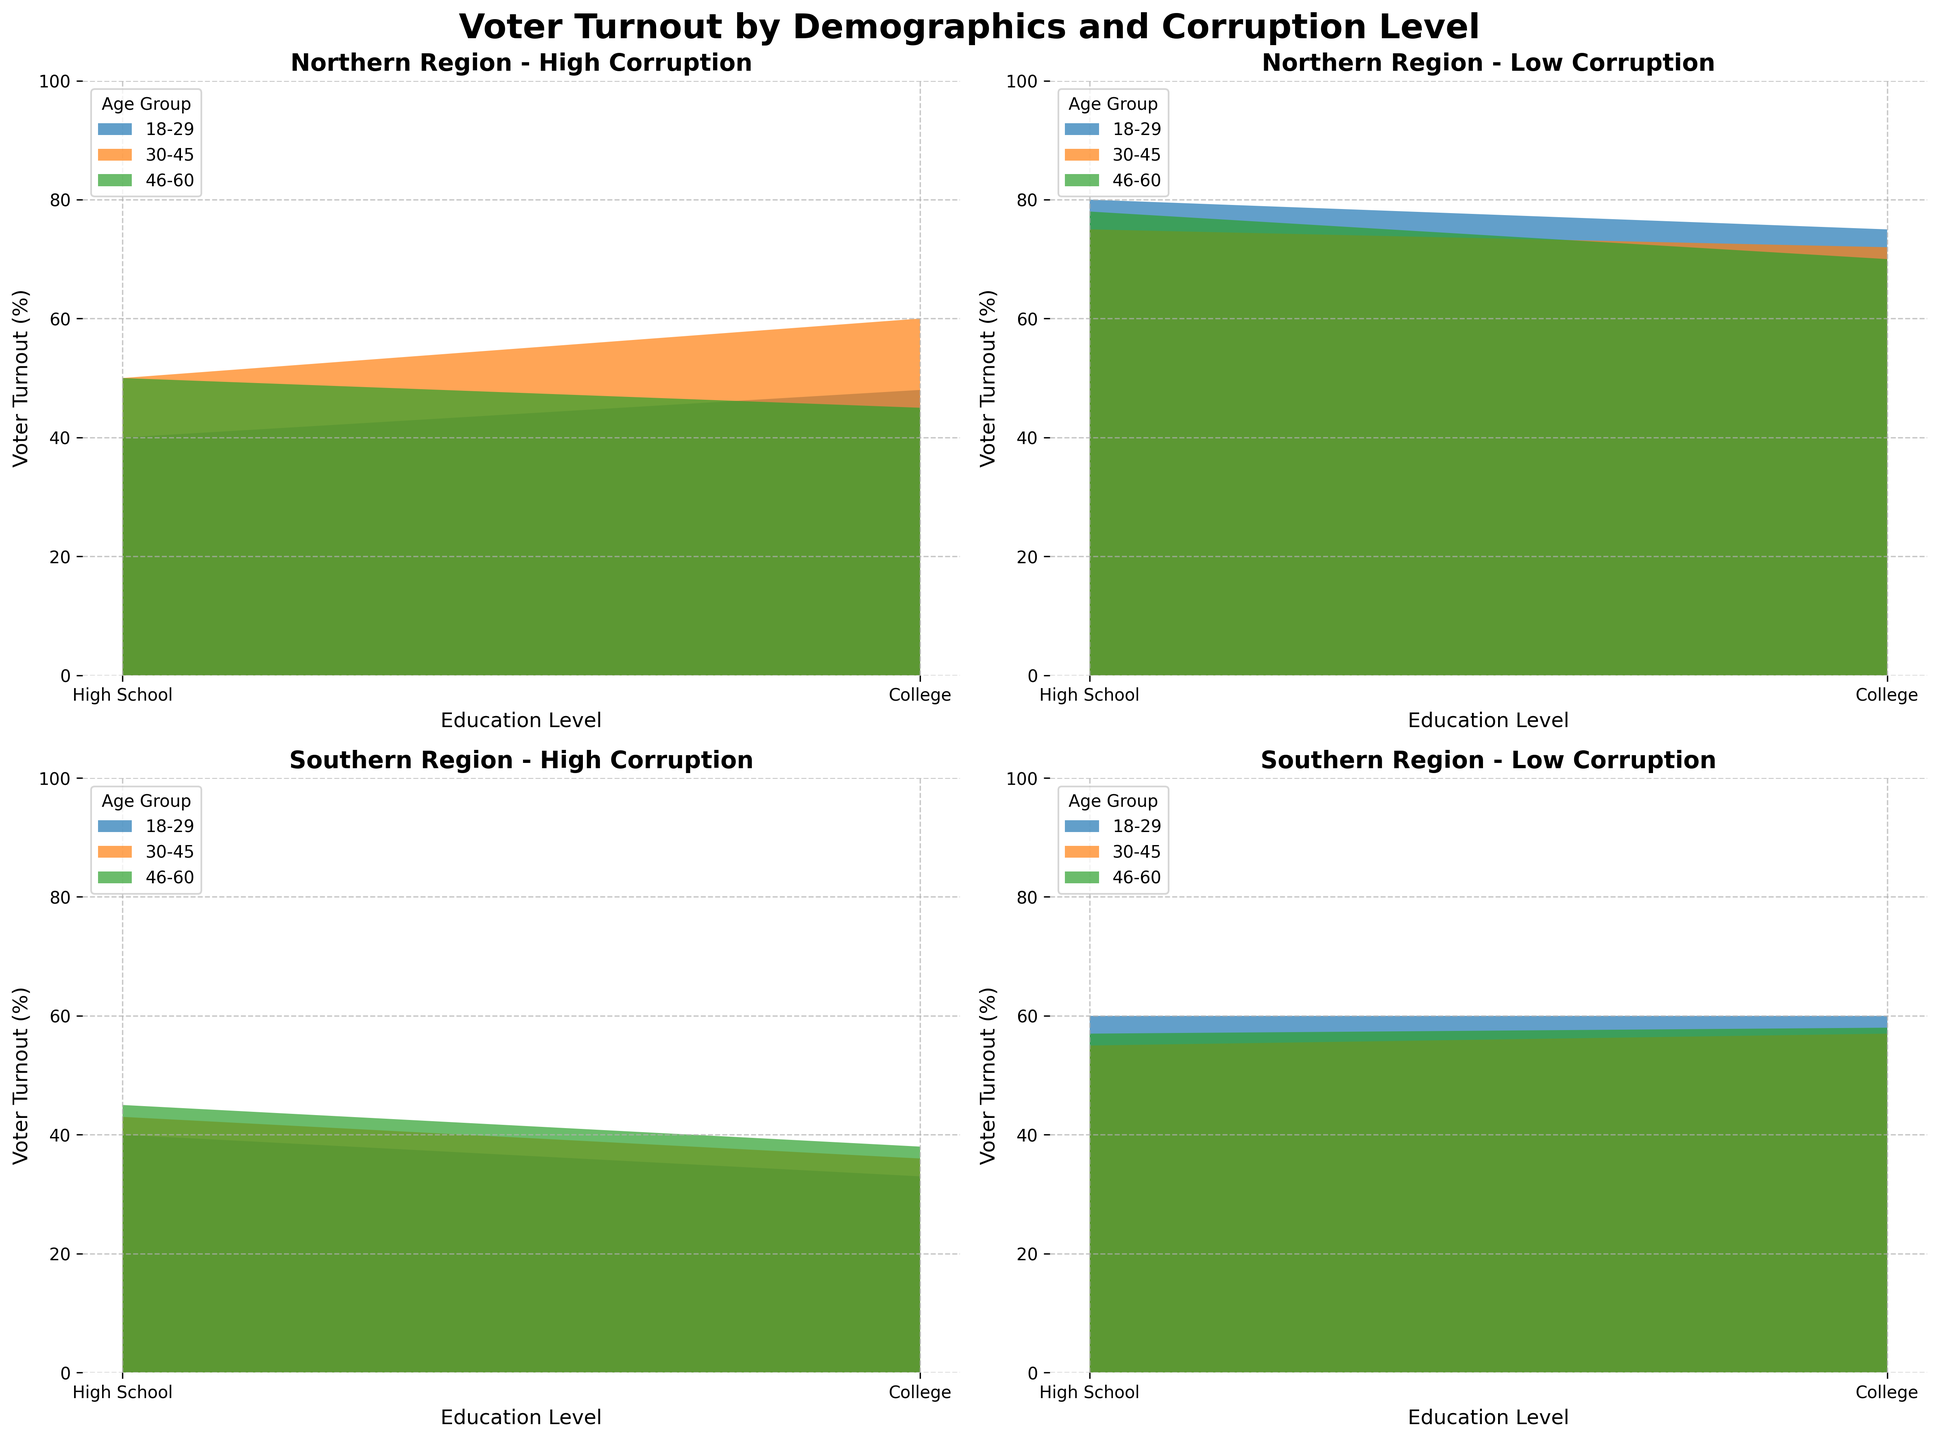What title is displayed at the top of the figure? The title is specified by the `suptitle` parameter in the `fig.suptitle` function. It should be evident at the very top center of the figure.
Answer: Voter Turnout by Demographics and Corruption Level How does voter turnout among college-educated individuals in the Northern region differ between high and low corruption levels? Observe the area charts for the Northern region under the high and low corruption conditions. Specifically, look at the differences in the voter turnout rates for the college-educated subgroup.
Answer: Higher in low corruption level Which age group generally has the highest voter turnout in regions with low corruption? Examine the area corresponding to the low corruption levels for both Northern and Southern regions. The highest area peak across the age groups will indicate the group with the highest voter turnout.
Answer: 18-29 Is there a noticeable difference in voter turnout between high school and college-educated individuals in the Southern region with low corruption? Compare the voter turnout areas for high school versus college education in the Southern region with low corruption. Look for general trends and differences in the areas representing these education levels.
Answer: Higher for college-educated In regions with high corruption, which age group tends to have the highest voter turnout for the Southern region? Look at the subplots for the Southern region with high corruption and identify the age group with the highest peaks in voter turnout.
Answer: 46-60 How does voter turnout among different age groups with high education level compare in both regions under low corruption? Compare the area charts for the college-educated individuals under low corruption for both Northern and Southern regions across different age groups. Determine which age group has consistently higher turnout.
Answer: Northern has higher turnout for 18-29 and 30-45, Southern for 46-60 What's the trend in voter turnout for the 30-45 age group in the Northern region under high and low corruption levels? Observe the specific area chart for the 30-45 age group in the Northern region. Compare the trends between high and low corruption levels for this group.
Answer: Increasing from high to low corruption Does the 46-60 age group in the Southern region show more voter turnout in high corruption areas compared to the Northern region? Compare the area segments for the 46-60 age group in high corruption areas between the Southern and Northern regions.
Answer: No What is the general trend of voter turnout by age group in Northern regions with low corruption? Examine the area pertaining to Northern regions with low corruption and identify the trend for different age groups' voter turnout.
Answer: Increases with age How do voter turnout rates for high school-educated people in high corruption areas compare between Northern and Southern regions? Compare the age-wise area charts for individuals with high school education in high corruption regions between Northern and Southern regions. Check for differences in the voter turnout rates.
Answer: Higher in Northern region 